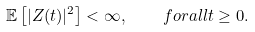Convert formula to latex. <formula><loc_0><loc_0><loc_500><loc_500>\mathbb { E } \left [ | Z ( t ) | ^ { 2 } \right ] < \infty , \quad f o r a l l t \geq 0 .</formula> 